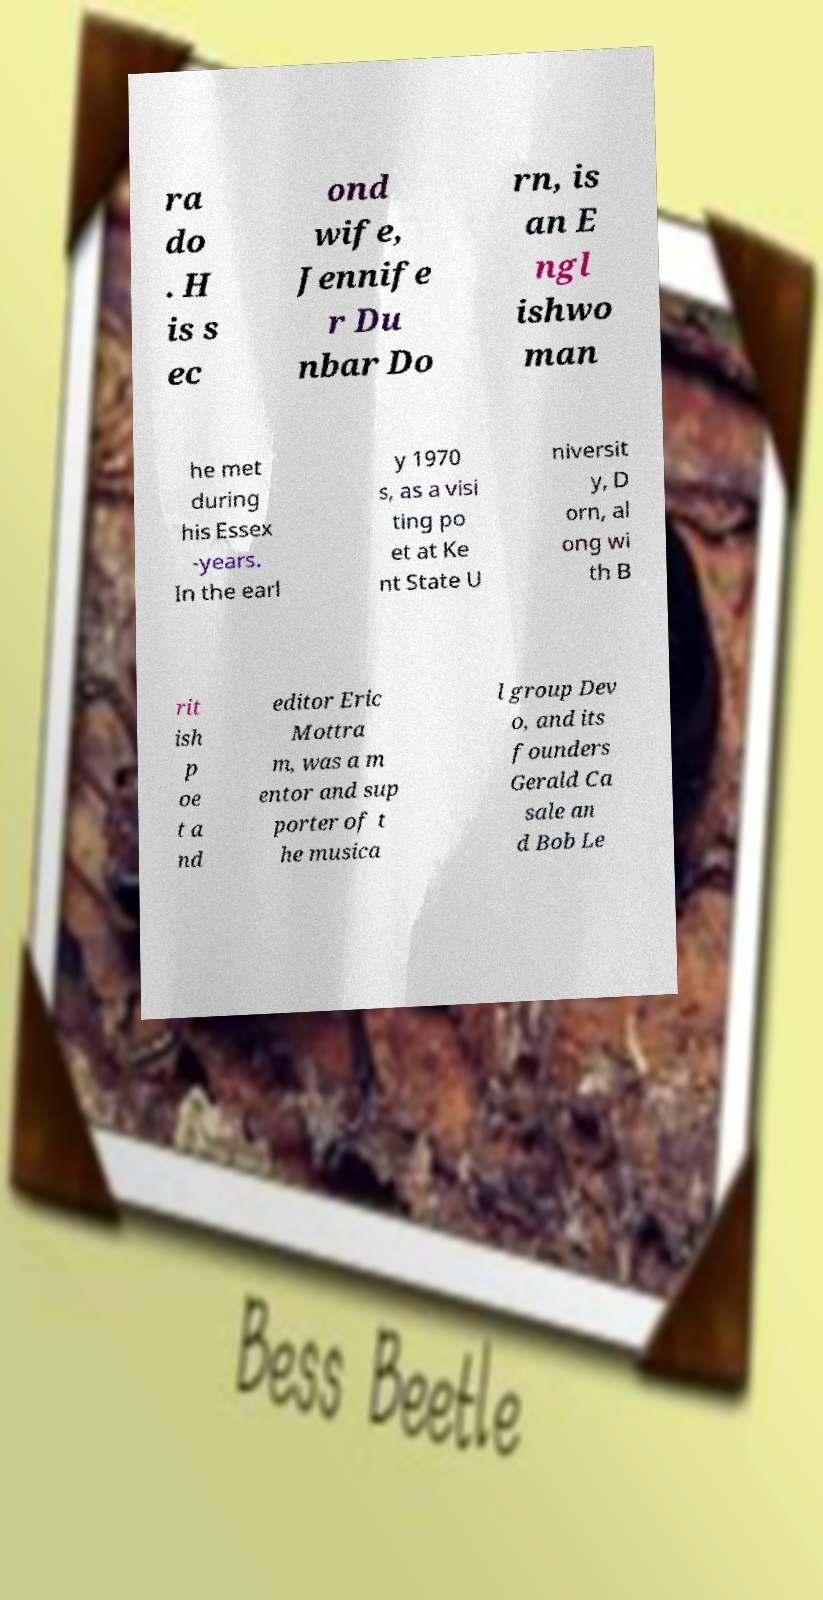I need the written content from this picture converted into text. Can you do that? ra do . H is s ec ond wife, Jennife r Du nbar Do rn, is an E ngl ishwo man he met during his Essex -years. In the earl y 1970 s, as a visi ting po et at Ke nt State U niversit y, D orn, al ong wi th B rit ish p oe t a nd editor Eric Mottra m, was a m entor and sup porter of t he musica l group Dev o, and its founders Gerald Ca sale an d Bob Le 